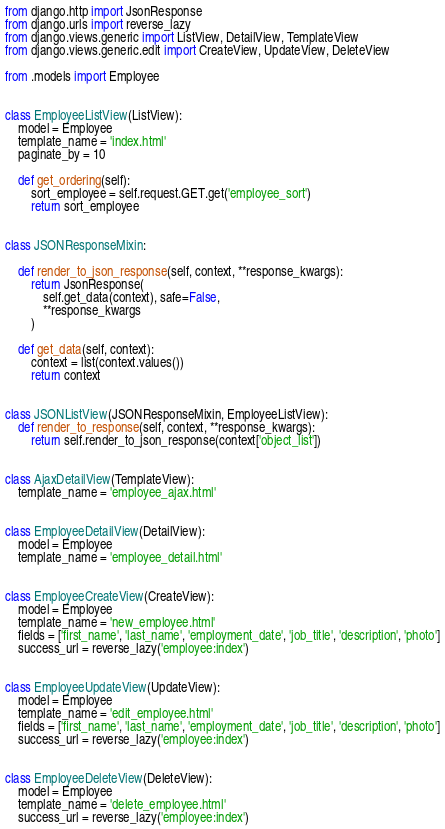<code> <loc_0><loc_0><loc_500><loc_500><_Python_>from django.http import JsonResponse
from django.urls import reverse_lazy
from django.views.generic import ListView, DetailView, TemplateView
from django.views.generic.edit import CreateView, UpdateView, DeleteView

from .models import Employee


class EmployeeListView(ListView):
    model = Employee
    template_name = 'index.html'
    paginate_by = 10

    def get_ordering(self):
        sort_employee = self.request.GET.get('employee_sort')
        return sort_employee


class JSONResponseMixin:

    def render_to_json_response(self, context, **response_kwargs):
        return JsonResponse(
            self.get_data(context), safe=False,
            **response_kwargs
        )

    def get_data(self, context):
        context = list(context.values())
        return context


class JSONListView(JSONResponseMixin, EmployeeListView):
    def render_to_response(self, context, **response_kwargs):
        return self.render_to_json_response(context['object_list'])


class AjaxDetailView(TemplateView):
    template_name = 'employee_ajax.html'


class EmployeeDetailView(DetailView):
    model = Employee
    template_name = 'employee_detail.html'


class EmployeeCreateView(CreateView):
    model = Employee
    template_name = 'new_employee.html'
    fields = ['first_name', 'last_name', 'employment_date', 'job_title', 'description', 'photo']
    success_url = reverse_lazy('employee:index')


class EmployeeUpdateView(UpdateView):
    model = Employee
    template_name = 'edit_employee.html'
    fields = ['first_name', 'last_name', 'employment_date', 'job_title', 'description', 'photo']
    success_url = reverse_lazy('employee:index')


class EmployeeDeleteView(DeleteView):
    model = Employee
    template_name = 'delete_employee.html'
    success_url = reverse_lazy('employee:index')
</code> 